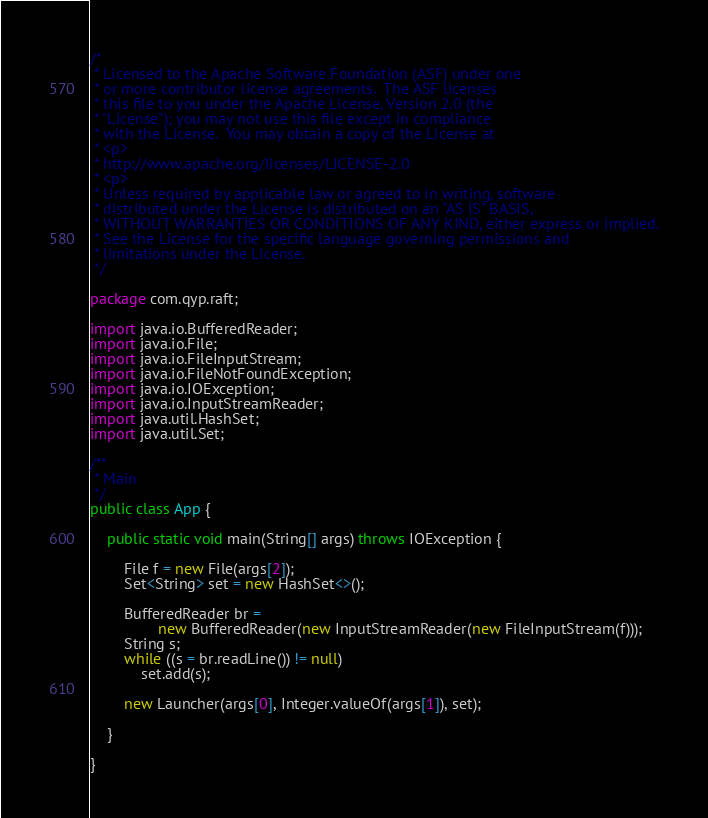<code> <loc_0><loc_0><loc_500><loc_500><_Java_>/*
 * Licensed to the Apache Software Foundation (ASF) under one
 * or more contributor license agreements.  The ASF licenses
 * this file to you under the Apache License, Version 2.0 (the
 * "License"); you may not use this file except in compliance
 * with the License.  You may obtain a copy of the License at
 * <p>
 * http://www.apache.org/licenses/LICENSE-2.0
 * <p>
 * Unless required by applicable law or agreed to in writing, software
 * distributed under the License is distributed on an "AS IS" BASIS,
 * WITHOUT WARRANTIES OR CONDITIONS OF ANY KIND, either express or implied.
 * See the License for the specific language governing permissions and
 * limitations under the License.
 */

package com.qyp.raft;

import java.io.BufferedReader;
import java.io.File;
import java.io.FileInputStream;
import java.io.FileNotFoundException;
import java.io.IOException;
import java.io.InputStreamReader;
import java.util.HashSet;
import java.util.Set;

/**
 * Main
 */
public class App {

    public static void main(String[] args) throws IOException {

        File f = new File(args[2]);
        Set<String> set = new HashSet<>();

        BufferedReader br =
                new BufferedReader(new InputStreamReader(new FileInputStream(f)));
        String s;
        while ((s = br.readLine()) != null)
            set.add(s);

        new Launcher(args[0], Integer.valueOf(args[1]), set);

    }

}
</code> 